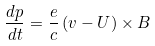Convert formula to latex. <formula><loc_0><loc_0><loc_500><loc_500>\frac { d p } { d t } = \frac { e } { c } \left ( v - U \right ) \times B</formula> 